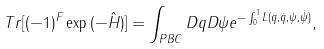Convert formula to latex. <formula><loc_0><loc_0><loc_500><loc_500>T r [ ( - 1 ) ^ { F } \exp { ( - \hat { H } ) } ] = \int _ { P B C } D q D \psi e ^ { - \int _ { 0 } ^ { 1 } L ( q , \dot { q } , \psi , \dot { \psi } ) } ,</formula> 